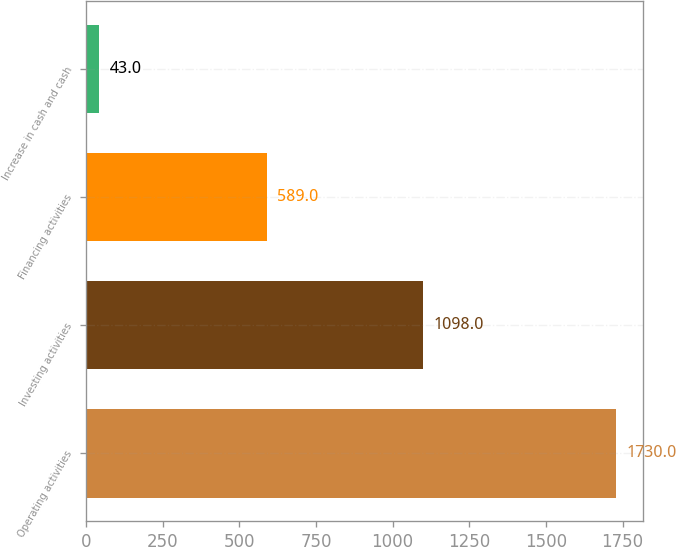Convert chart. <chart><loc_0><loc_0><loc_500><loc_500><bar_chart><fcel>Operating activities<fcel>Investing activities<fcel>Financing activities<fcel>Increase in cash and cash<nl><fcel>1730<fcel>1098<fcel>589<fcel>43<nl></chart> 